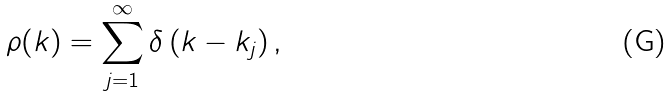<formula> <loc_0><loc_0><loc_500><loc_500>\rho ( k ) = \sum _ { j = 1 } ^ { \infty } \delta \left ( k - k _ { j } \right ) ,</formula> 